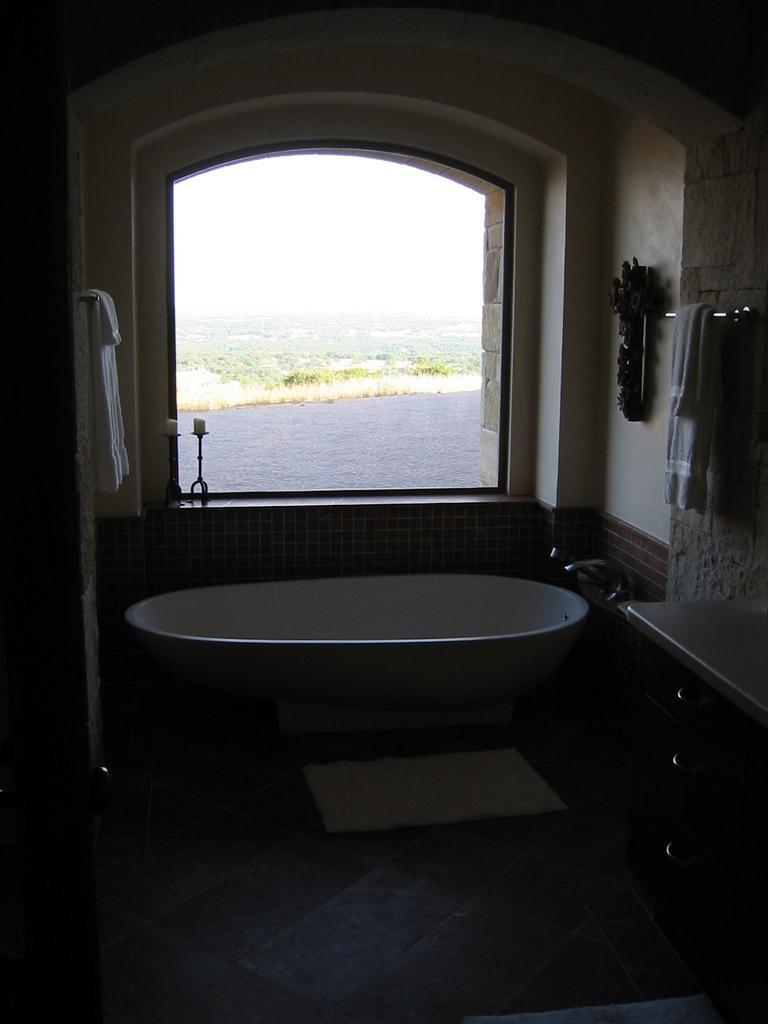Can you describe this image briefly? In the picture we can see a washroom with a bathtub and near it, we can see taps and beside it, we can see a desk and into the wall we can see a towel hanged and beside the washtub we can see a window, from it we can see water surface and behind it we can see grass surface and the sky. 